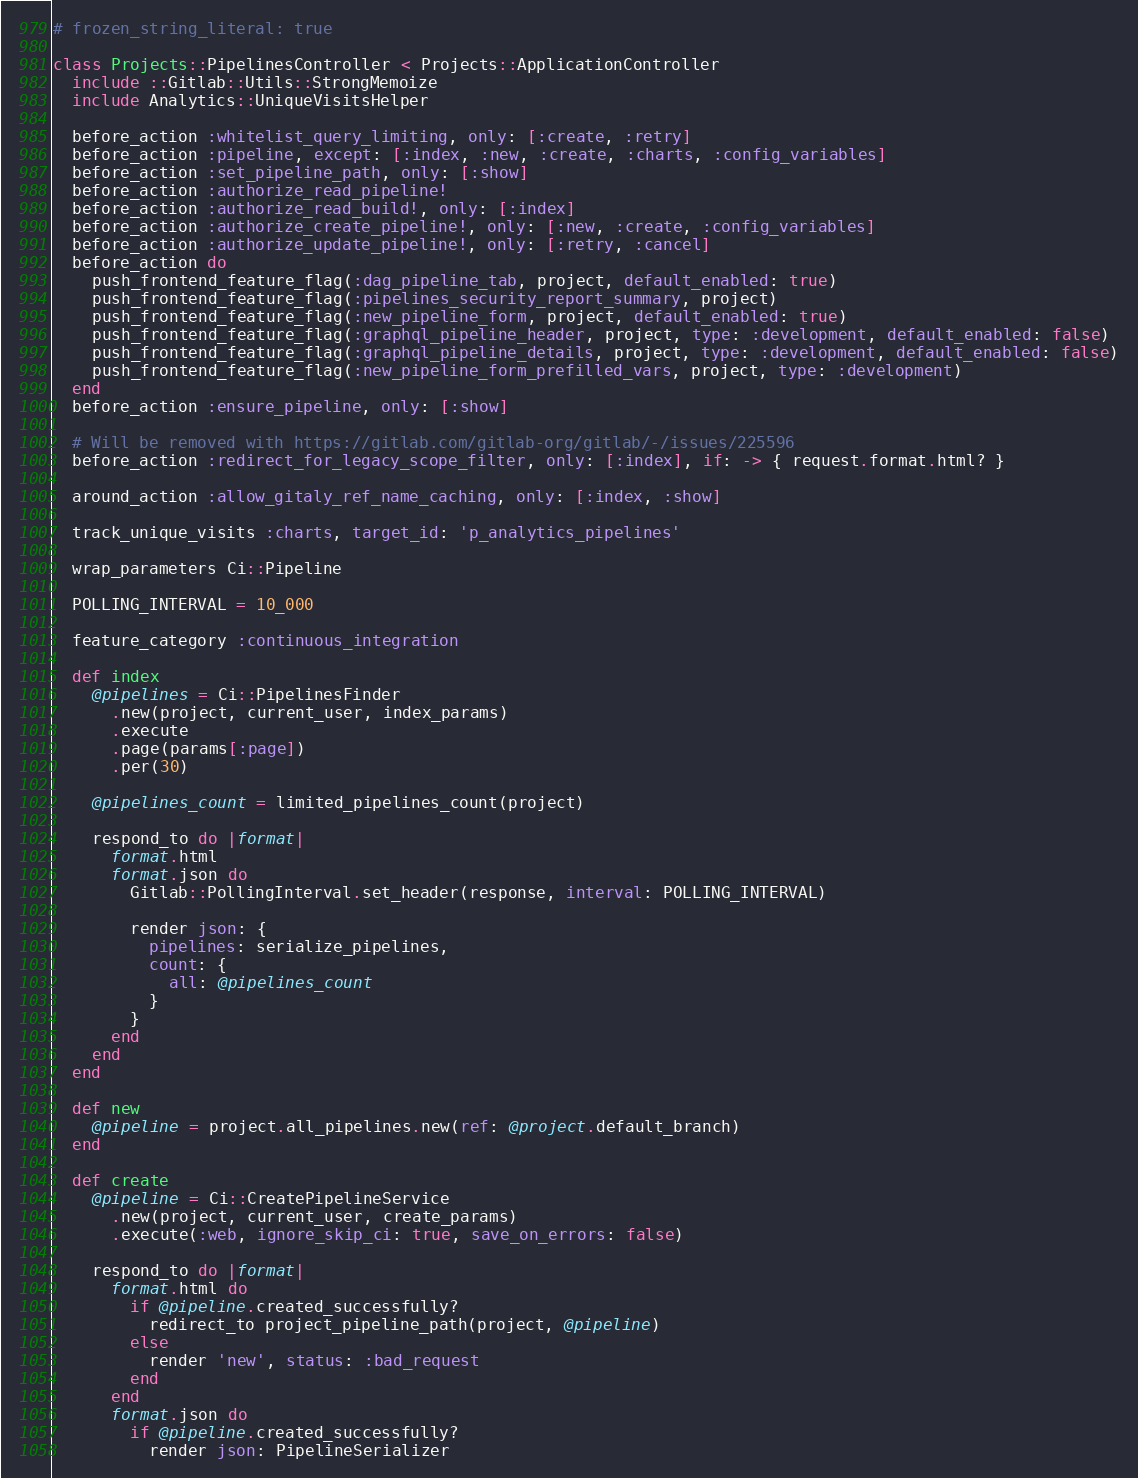<code> <loc_0><loc_0><loc_500><loc_500><_Ruby_># frozen_string_literal: true

class Projects::PipelinesController < Projects::ApplicationController
  include ::Gitlab::Utils::StrongMemoize
  include Analytics::UniqueVisitsHelper

  before_action :whitelist_query_limiting, only: [:create, :retry]
  before_action :pipeline, except: [:index, :new, :create, :charts, :config_variables]
  before_action :set_pipeline_path, only: [:show]
  before_action :authorize_read_pipeline!
  before_action :authorize_read_build!, only: [:index]
  before_action :authorize_create_pipeline!, only: [:new, :create, :config_variables]
  before_action :authorize_update_pipeline!, only: [:retry, :cancel]
  before_action do
    push_frontend_feature_flag(:dag_pipeline_tab, project, default_enabled: true)
    push_frontend_feature_flag(:pipelines_security_report_summary, project)
    push_frontend_feature_flag(:new_pipeline_form, project, default_enabled: true)
    push_frontend_feature_flag(:graphql_pipeline_header, project, type: :development, default_enabled: false)
    push_frontend_feature_flag(:graphql_pipeline_details, project, type: :development, default_enabled: false)
    push_frontend_feature_flag(:new_pipeline_form_prefilled_vars, project, type: :development)
  end
  before_action :ensure_pipeline, only: [:show]

  # Will be removed with https://gitlab.com/gitlab-org/gitlab/-/issues/225596
  before_action :redirect_for_legacy_scope_filter, only: [:index], if: -> { request.format.html? }

  around_action :allow_gitaly_ref_name_caching, only: [:index, :show]

  track_unique_visits :charts, target_id: 'p_analytics_pipelines'

  wrap_parameters Ci::Pipeline

  POLLING_INTERVAL = 10_000

  feature_category :continuous_integration

  def index
    @pipelines = Ci::PipelinesFinder
      .new(project, current_user, index_params)
      .execute
      .page(params[:page])
      .per(30)

    @pipelines_count = limited_pipelines_count(project)

    respond_to do |format|
      format.html
      format.json do
        Gitlab::PollingInterval.set_header(response, interval: POLLING_INTERVAL)

        render json: {
          pipelines: serialize_pipelines,
          count: {
            all: @pipelines_count
          }
        }
      end
    end
  end

  def new
    @pipeline = project.all_pipelines.new(ref: @project.default_branch)
  end

  def create
    @pipeline = Ci::CreatePipelineService
      .new(project, current_user, create_params)
      .execute(:web, ignore_skip_ci: true, save_on_errors: false)

    respond_to do |format|
      format.html do
        if @pipeline.created_successfully?
          redirect_to project_pipeline_path(project, @pipeline)
        else
          render 'new', status: :bad_request
        end
      end
      format.json do
        if @pipeline.created_successfully?
          render json: PipelineSerializer</code> 